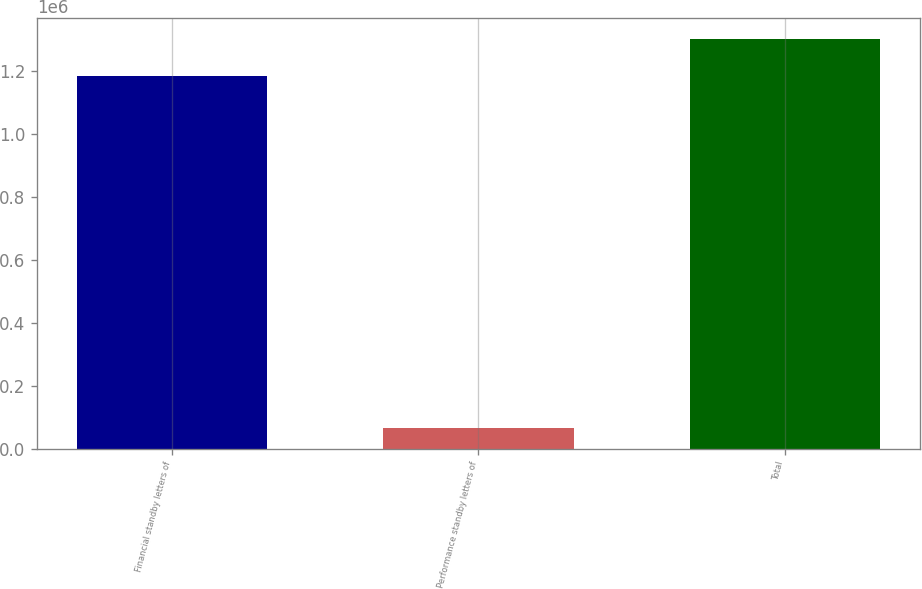Convert chart. <chart><loc_0><loc_0><loc_500><loc_500><bar_chart><fcel>Financial standby letters of<fcel>Performance standby letters of<fcel>Total<nl><fcel>1.18388e+06<fcel>64191<fcel>1.3029e+06<nl></chart> 